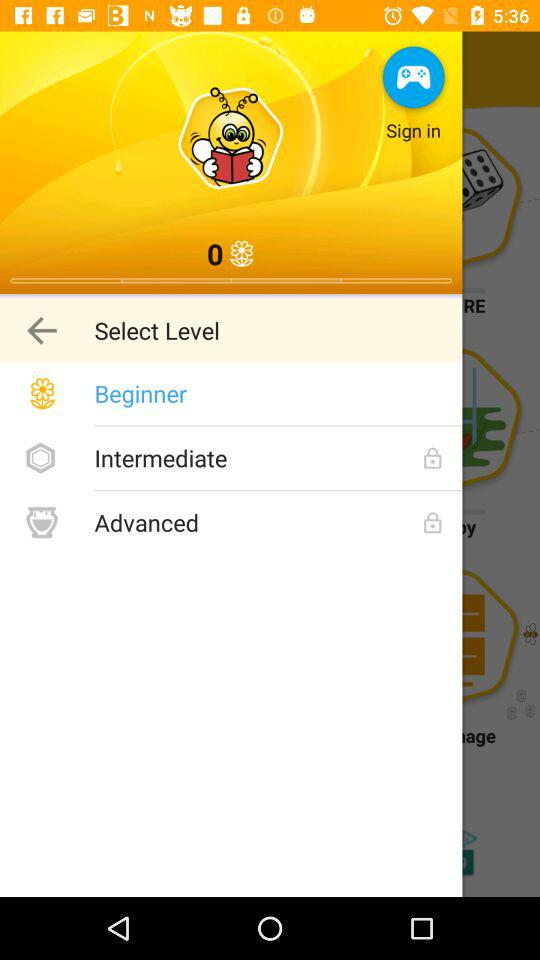How many levels are there?
Answer the question using a single word or phrase. 3 